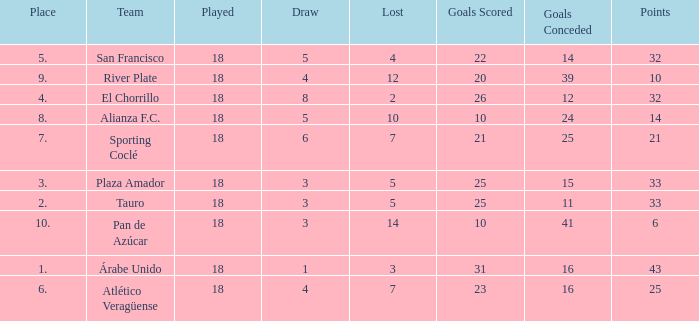How many points did the team have that conceded 41 goals and finish in a place larger than 10? 0.0. 